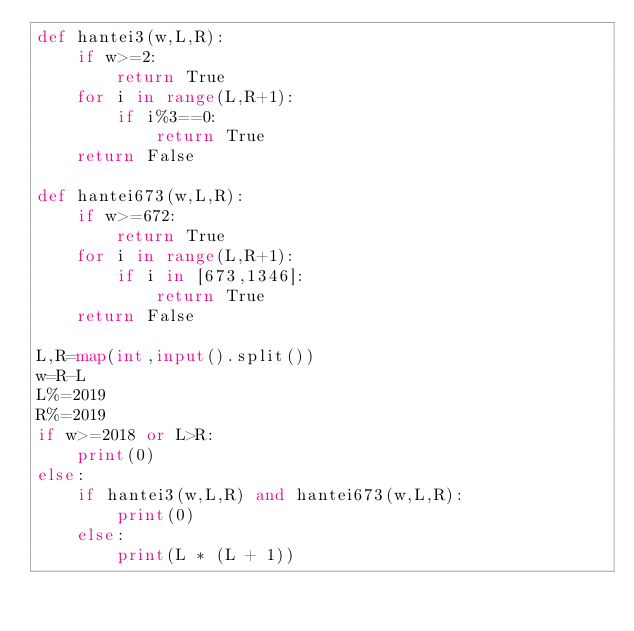<code> <loc_0><loc_0><loc_500><loc_500><_Python_>def hantei3(w,L,R):
    if w>=2:
        return True
    for i in range(L,R+1):
        if i%3==0:
            return True
    return False

def hantei673(w,L,R):
    if w>=672:
        return True
    for i in range(L,R+1):
        if i in [673,1346]:
            return True
    return False

L,R=map(int,input().split())
w=R-L
L%=2019
R%=2019
if w>=2018 or L>R:
    print(0)
else:
    if hantei3(w,L,R) and hantei673(w,L,R):
        print(0)
    else:
        print(L * (L + 1))
</code> 